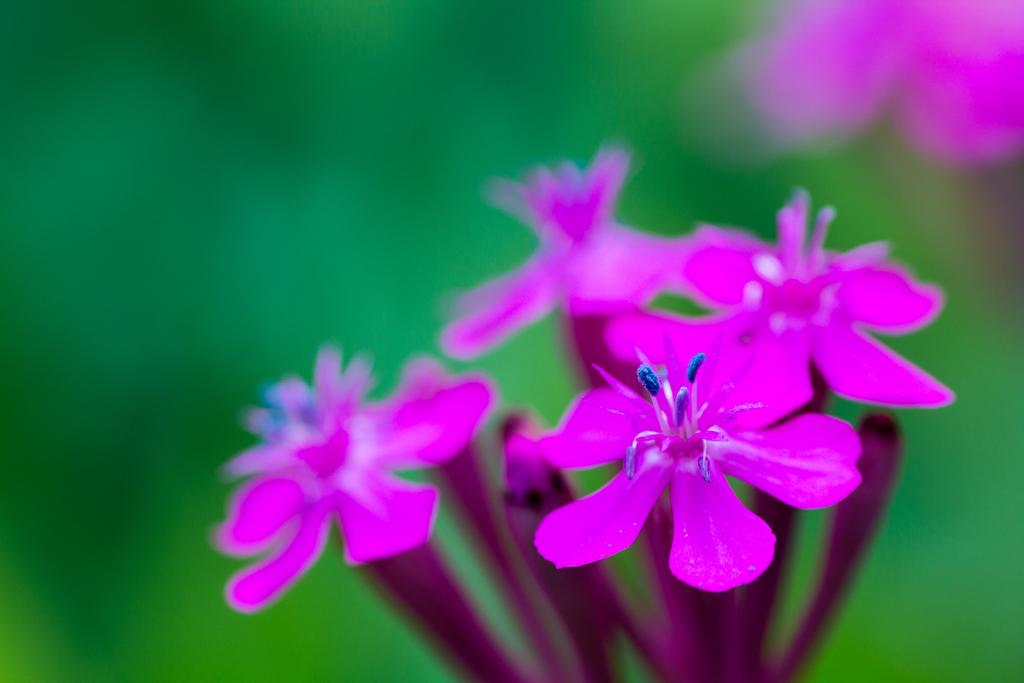What type of plants are in the image? There are flowers in the image. What color are the flowers? The flowers are purple. What color is the background of the image? The background of the image is green. How many tickets are visible in the image? There are no tickets present in the image. What type of toys can be seen in the image? There are no toys present in the image. 